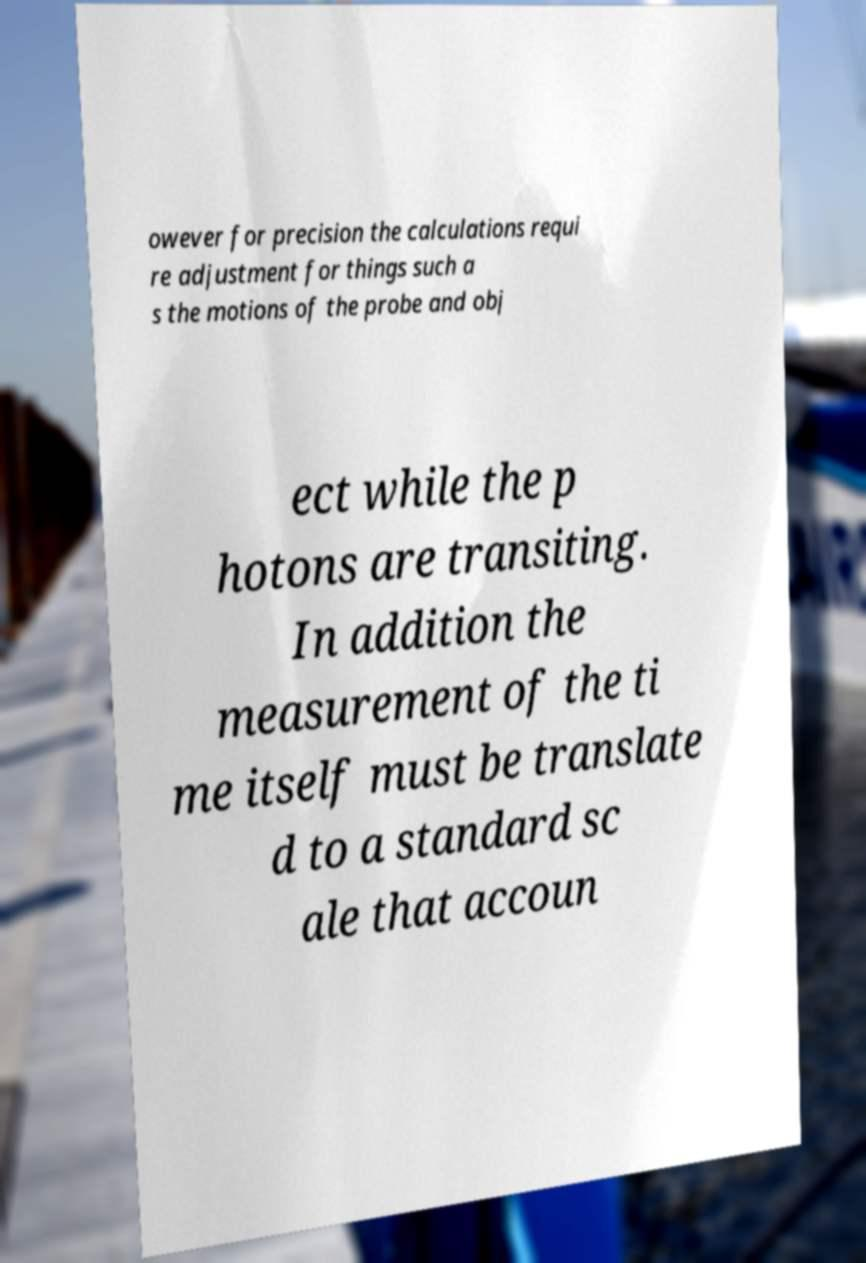Could you assist in decoding the text presented in this image and type it out clearly? owever for precision the calculations requi re adjustment for things such a s the motions of the probe and obj ect while the p hotons are transiting. In addition the measurement of the ti me itself must be translate d to a standard sc ale that accoun 